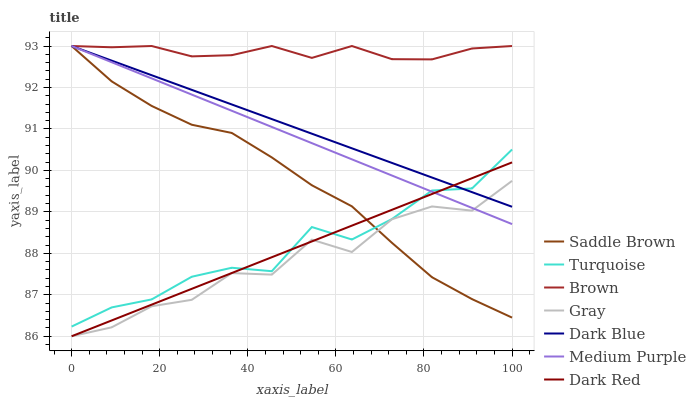Does Gray have the minimum area under the curve?
Answer yes or no. Yes. Does Brown have the maximum area under the curve?
Answer yes or no. Yes. Does Turquoise have the minimum area under the curve?
Answer yes or no. No. Does Turquoise have the maximum area under the curve?
Answer yes or no. No. Is Dark Red the smoothest?
Answer yes or no. Yes. Is Gray the roughest?
Answer yes or no. Yes. Is Turquoise the smoothest?
Answer yes or no. No. Is Turquoise the roughest?
Answer yes or no. No. Does Gray have the lowest value?
Answer yes or no. Yes. Does Turquoise have the lowest value?
Answer yes or no. No. Does Saddle Brown have the highest value?
Answer yes or no. Yes. Does Turquoise have the highest value?
Answer yes or no. No. Is Gray less than Brown?
Answer yes or no. Yes. Is Brown greater than Turquoise?
Answer yes or no. Yes. Does Dark Blue intersect Dark Red?
Answer yes or no. Yes. Is Dark Blue less than Dark Red?
Answer yes or no. No. Is Dark Blue greater than Dark Red?
Answer yes or no. No. Does Gray intersect Brown?
Answer yes or no. No. 